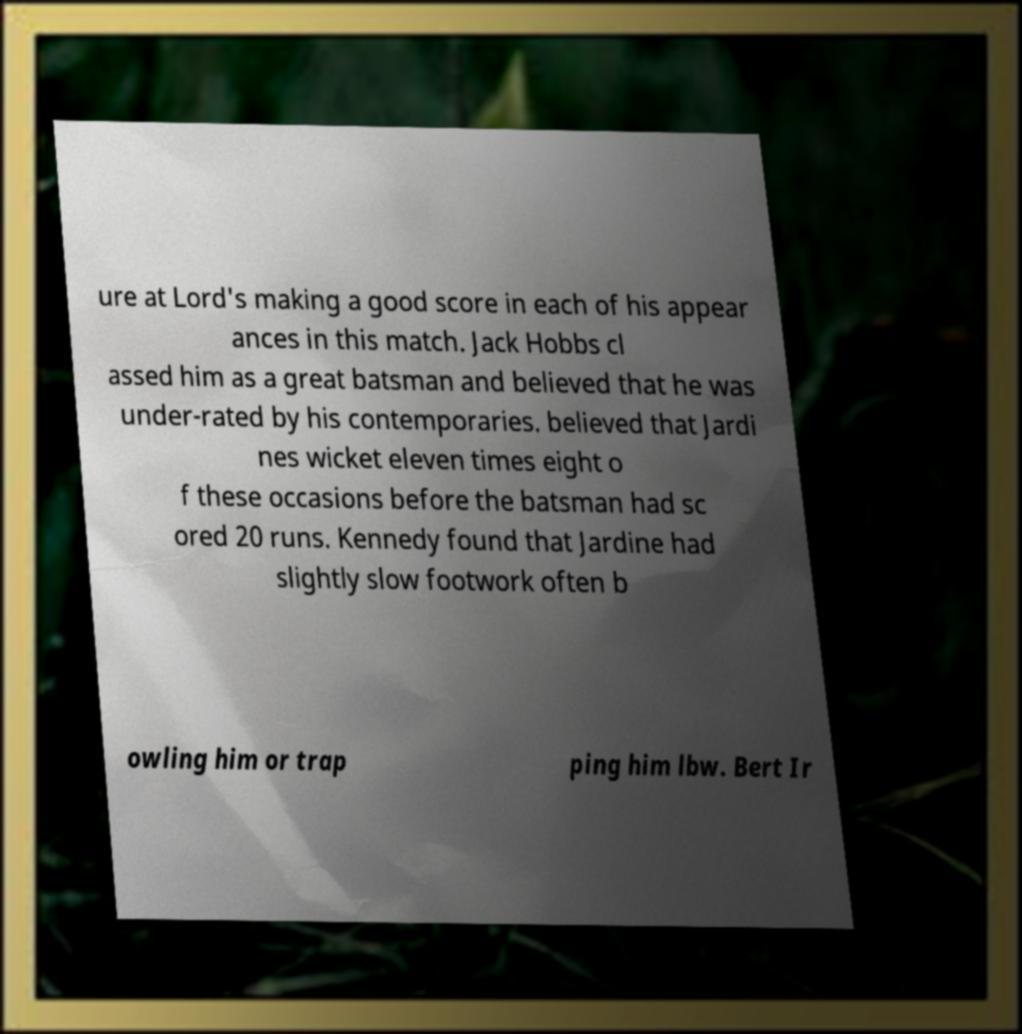There's text embedded in this image that I need extracted. Can you transcribe it verbatim? ure at Lord's making a good score in each of his appear ances in this match. Jack Hobbs cl assed him as a great batsman and believed that he was under-rated by his contemporaries. believed that Jardi nes wicket eleven times eight o f these occasions before the batsman had sc ored 20 runs. Kennedy found that Jardine had slightly slow footwork often b owling him or trap ping him lbw. Bert Ir 